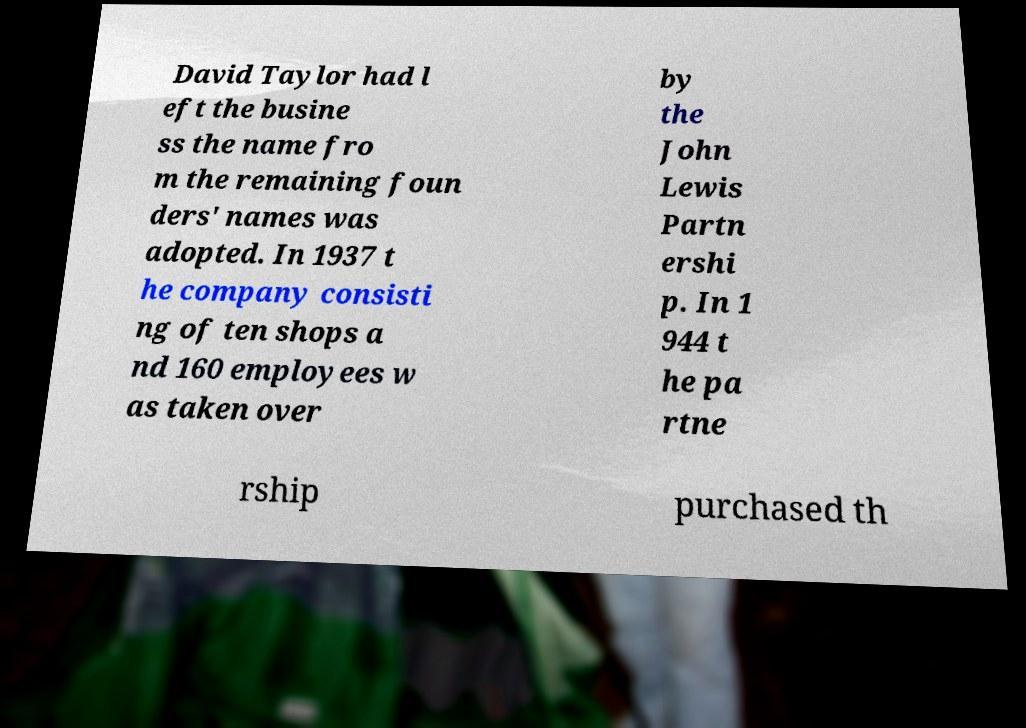What messages or text are displayed in this image? I need them in a readable, typed format. David Taylor had l eft the busine ss the name fro m the remaining foun ders' names was adopted. In 1937 t he company consisti ng of ten shops a nd 160 employees w as taken over by the John Lewis Partn ershi p. In 1 944 t he pa rtne rship purchased th 